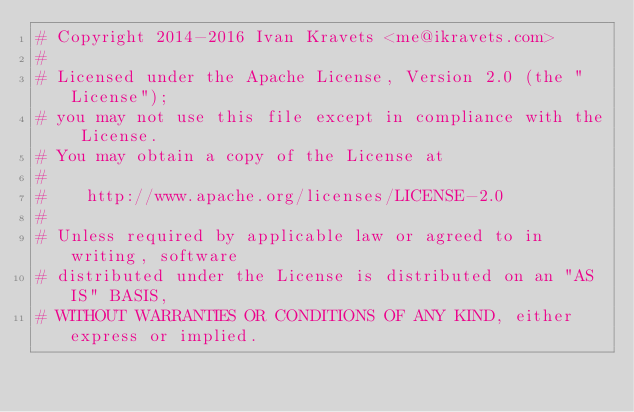<code> <loc_0><loc_0><loc_500><loc_500><_Python_># Copyright 2014-2016 Ivan Kravets <me@ikravets.com>
#
# Licensed under the Apache License, Version 2.0 (the "License");
# you may not use this file except in compliance with the License.
# You may obtain a copy of the License at
#
#    http://www.apache.org/licenses/LICENSE-2.0
#
# Unless required by applicable law or agreed to in writing, software
# distributed under the License is distributed on an "AS IS" BASIS,
# WITHOUT WARRANTIES OR CONDITIONS OF ANY KIND, either express or implied.</code> 